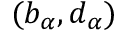<formula> <loc_0><loc_0><loc_500><loc_500>( b _ { \alpha } , d _ { \alpha } )</formula> 